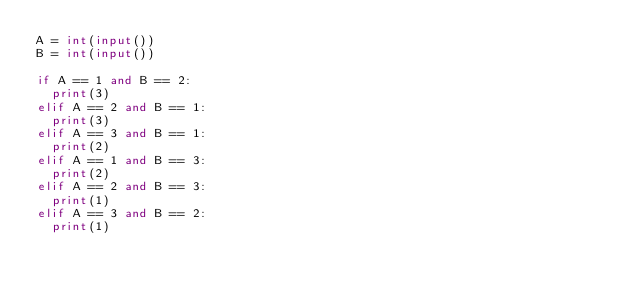<code> <loc_0><loc_0><loc_500><loc_500><_Python_>A = int(input())
B = int(input())

if A == 1 and B == 2:
  print(3)
elif A == 2 and B == 1:
  print(3)
elif A == 3 and B == 1:
  print(2)
elif A == 1 and B == 3:
  print(2)  
elif A == 2 and B == 3:
  print(1)
elif A == 3 and B == 2:
  print(1)</code> 